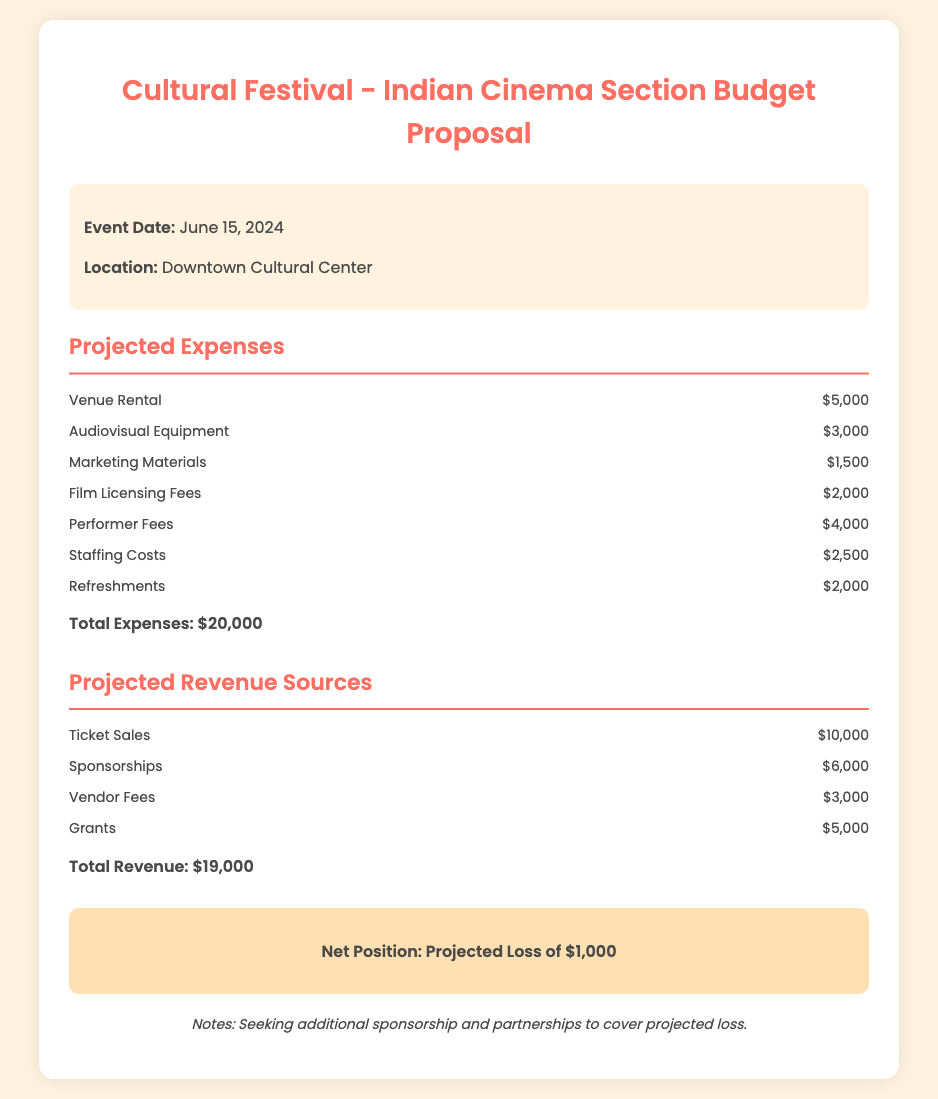What is the event date? The document states that the event date is June 15, 2024.
Answer: June 15, 2024 What is the total expense amount? The total amount of expenses listed in the document is $20,000.
Answer: $20,000 How much is allocated for performer fees? The document specifies that performer fees are budgeted at $4,000.
Answer: $4,000 What is the projected loss for the event? The net position indicates a projected loss of $1,000.
Answer: Projected Loss of $1,000 What are the projected revenue sources? The document lists multiple revenue sources, including ticket sales, sponsorships, vendor fees, and grants.
Answer: Ticket Sales, Sponsorships, Vendor Fees, Grants Which expense category has the highest cost? The highest expense category is venue rental, with a cost of $5,000.
Answer: Venue Rental What is the total revenue amount? The total revenue amount, as calculated from the revenue sources, is $19,000.
Answer: $19,000 What is the location of the event? The document mentions the location as Downtown Cultural Center.
Answer: Downtown Cultural Center What is the total amount for marketing materials? The total allocated for marketing materials in the budget is $1,500.
Answer: $1,500 